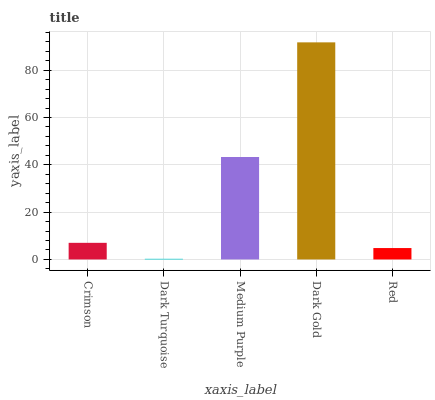Is Dark Turquoise the minimum?
Answer yes or no. Yes. Is Dark Gold the maximum?
Answer yes or no. Yes. Is Medium Purple the minimum?
Answer yes or no. No. Is Medium Purple the maximum?
Answer yes or no. No. Is Medium Purple greater than Dark Turquoise?
Answer yes or no. Yes. Is Dark Turquoise less than Medium Purple?
Answer yes or no. Yes. Is Dark Turquoise greater than Medium Purple?
Answer yes or no. No. Is Medium Purple less than Dark Turquoise?
Answer yes or no. No. Is Crimson the high median?
Answer yes or no. Yes. Is Crimson the low median?
Answer yes or no. Yes. Is Dark Turquoise the high median?
Answer yes or no. No. Is Red the low median?
Answer yes or no. No. 